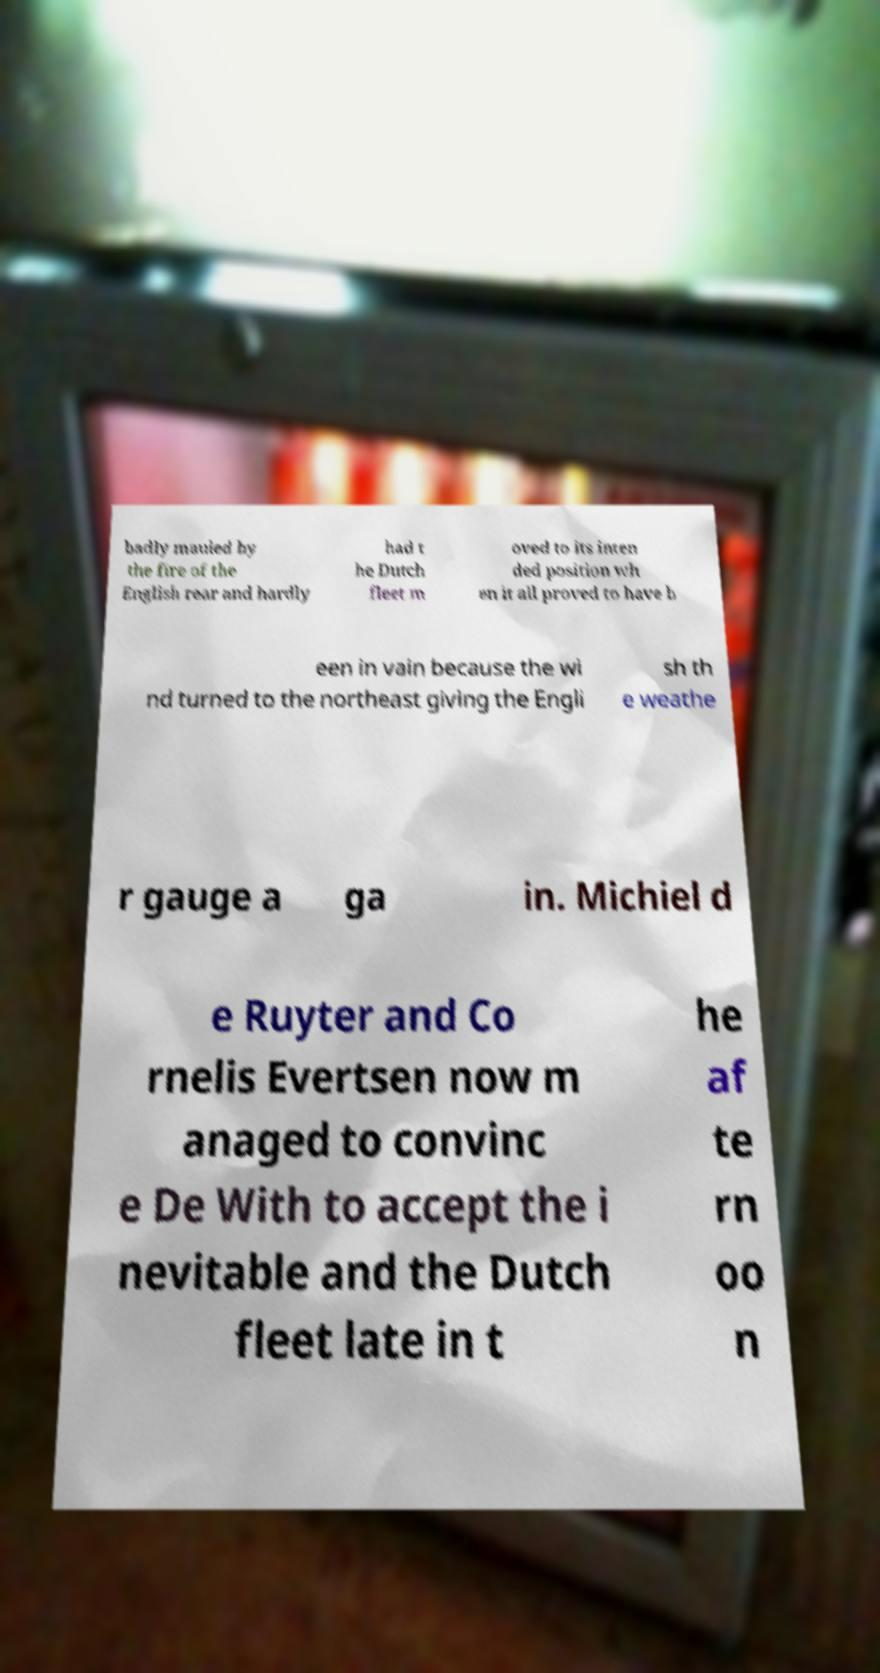I need the written content from this picture converted into text. Can you do that? badly mauled by the fire of the English rear and hardly had t he Dutch fleet m oved to its inten ded position wh en it all proved to have b een in vain because the wi nd turned to the northeast giving the Engli sh th e weathe r gauge a ga in. Michiel d e Ruyter and Co rnelis Evertsen now m anaged to convinc e De With to accept the i nevitable and the Dutch fleet late in t he af te rn oo n 